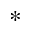<formula> <loc_0><loc_0><loc_500><loc_500>^ { * }</formula> 